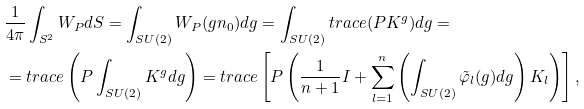Convert formula to latex. <formula><loc_0><loc_0><loc_500><loc_500>& \frac { 1 } { 4 \pi } \int _ { S ^ { 2 } } W _ { P } d S = \int _ { S U ( 2 ) } W _ { P } ( g n _ { 0 } ) d g = \int _ { S U ( 2 ) } t r a c e ( P K ^ { g } ) d g = \\ & = t r a c e \left ( P \int _ { S U ( 2 ) } K ^ { g } d g \right ) = t r a c e \left [ P \left ( \frac { 1 } { n + 1 } I + \sum _ { l = 1 } ^ { n } \left ( \int _ { S U ( 2 ) } \tilde { \varphi } _ { l } ( g ) d g \right ) K _ { l } \right ) \right ] ,</formula> 